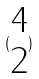Convert formula to latex. <formula><loc_0><loc_0><loc_500><loc_500>( \begin{matrix} 4 \\ 2 \end{matrix} )</formula> 